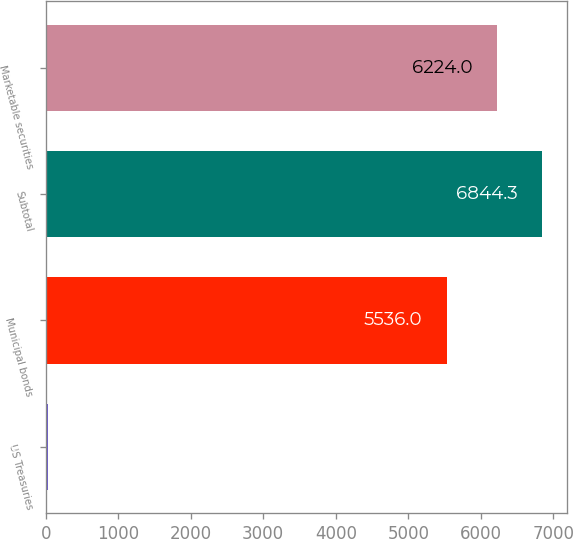Convert chart. <chart><loc_0><loc_0><loc_500><loc_500><bar_chart><fcel>US Treasuries<fcel>Municipal bonds<fcel>Subtotal<fcel>Marketable securities<nl><fcel>37<fcel>5536<fcel>6844.3<fcel>6224<nl></chart> 